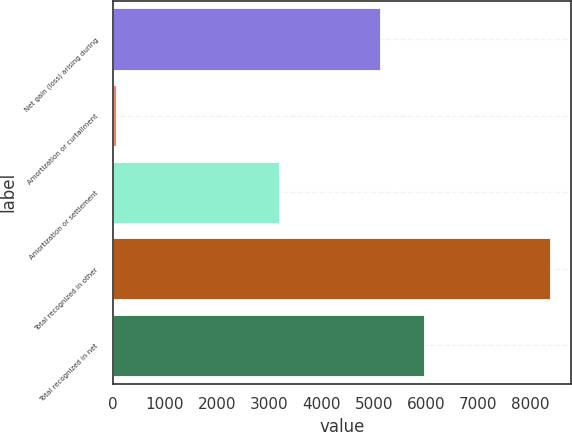<chart> <loc_0><loc_0><loc_500><loc_500><bar_chart><fcel>Net gain (loss) arising during<fcel>Amortization or curtailment<fcel>Amortization or settlement<fcel>Total recognized in other<fcel>Total recognized in net<nl><fcel>5128<fcel>62<fcel>3180<fcel>8370<fcel>5958.8<nl></chart> 